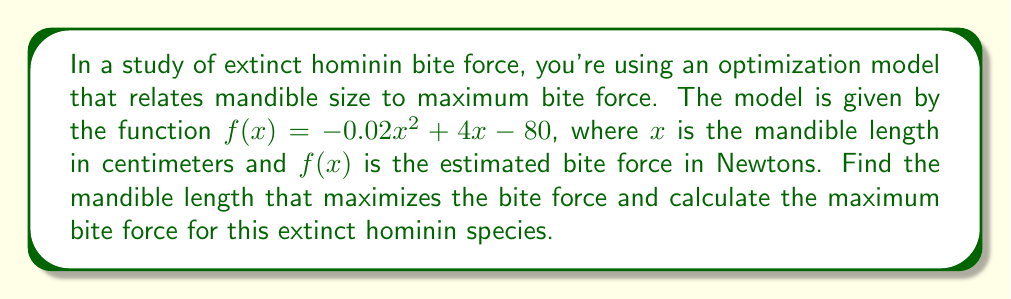Give your solution to this math problem. 1) To find the mandible length that maximizes the bite force, we need to find the maximum of the function $f(x) = -0.02x^2 + 4x - 80$.

2) The maximum of a quadratic function occurs at the vertex of the parabola. For a quadratic function in the form $f(x) = ax^2 + bx + c$, the x-coordinate of the vertex is given by $x = -\frac{b}{2a}$.

3) In our case, $a = -0.02$, $b = 4$, and $c = -80$. Let's substitute these values:

   $x = -\frac{4}{2(-0.02)} = -\frac{4}{-0.04} = 100$

4) Therefore, the mandible length that maximizes the bite force is 100 cm.

5) To find the maximum bite force, we substitute $x = 100$ into our original function:

   $f(100) = -0.02(100)^2 + 4(100) - 80$
           $= -0.02(10000) + 400 - 80$
           $= -200 + 400 - 80$
           $= 120$

6) Thus, the maximum bite force is 120 Newtons.
Answer: Mandible length: 100 cm; Maximum bite force: 120 N 